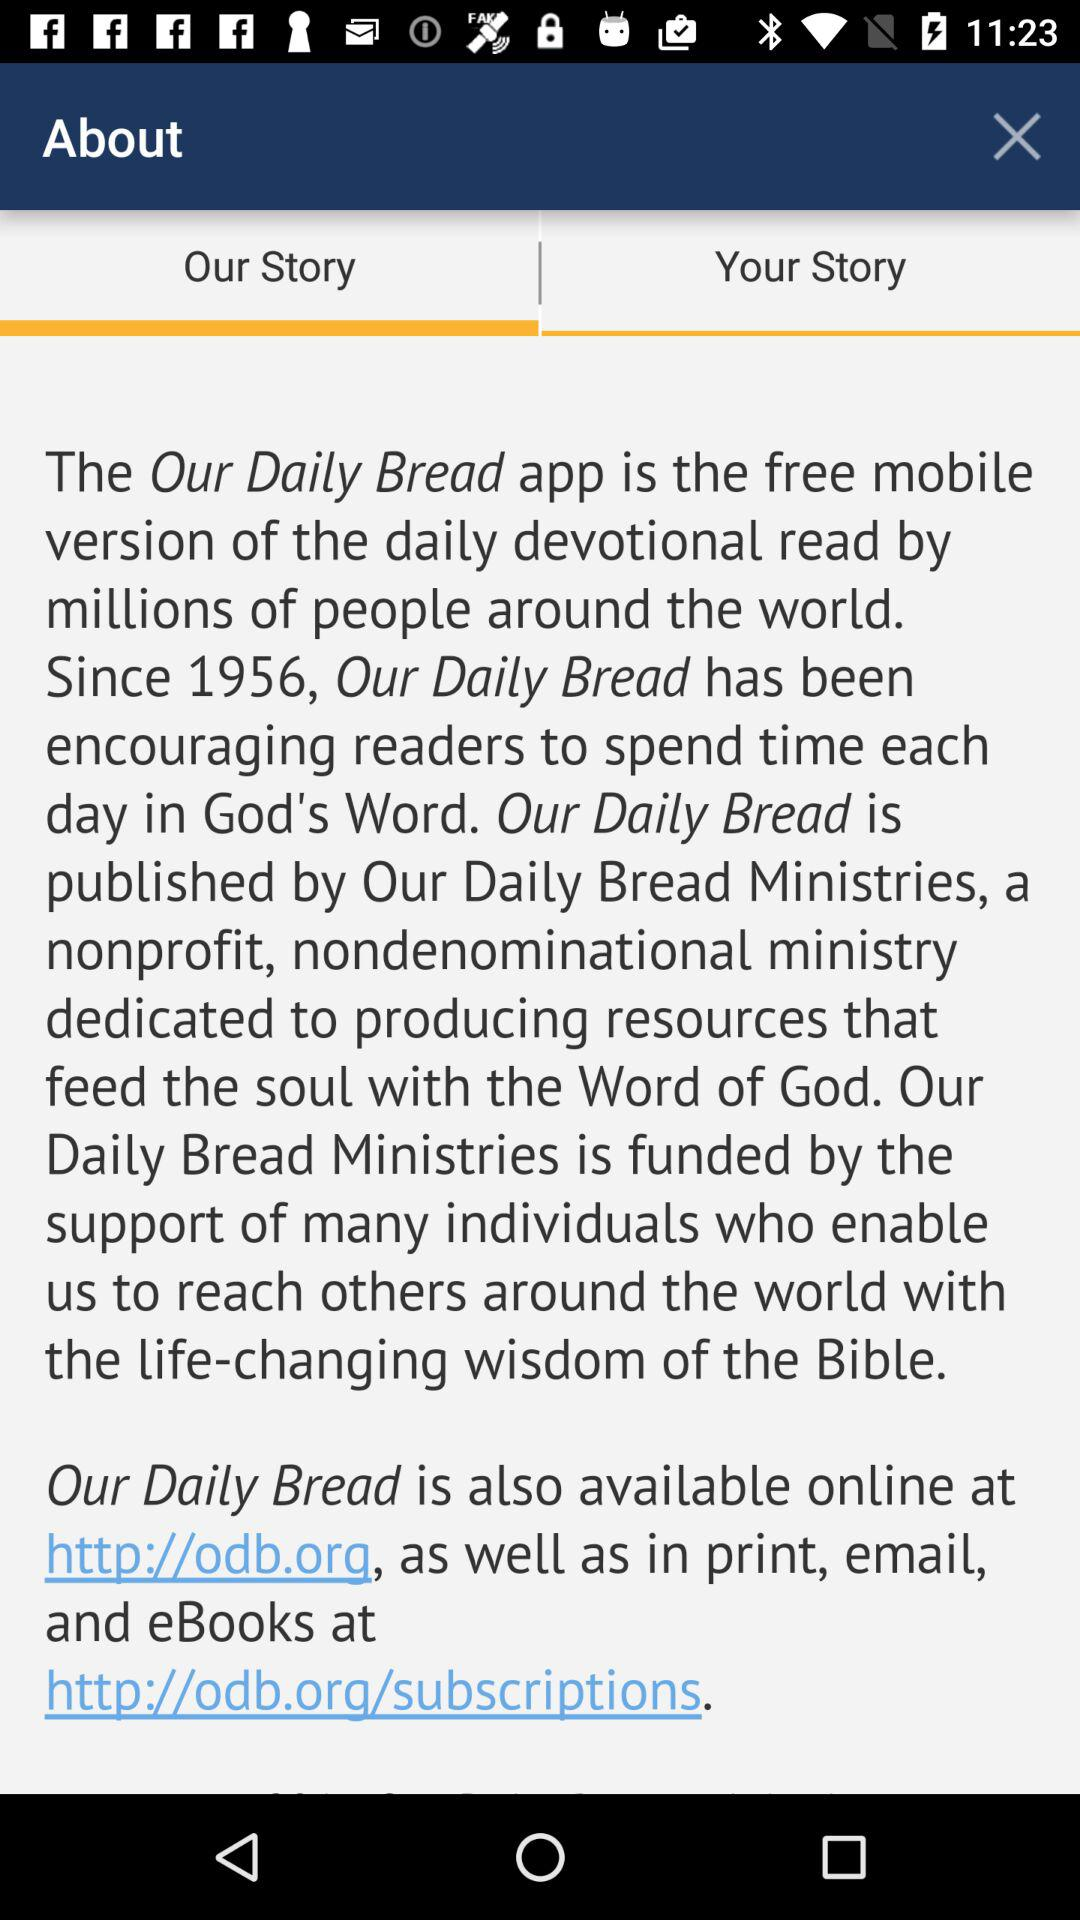Which option is selected? The selected option is "Our Story". 